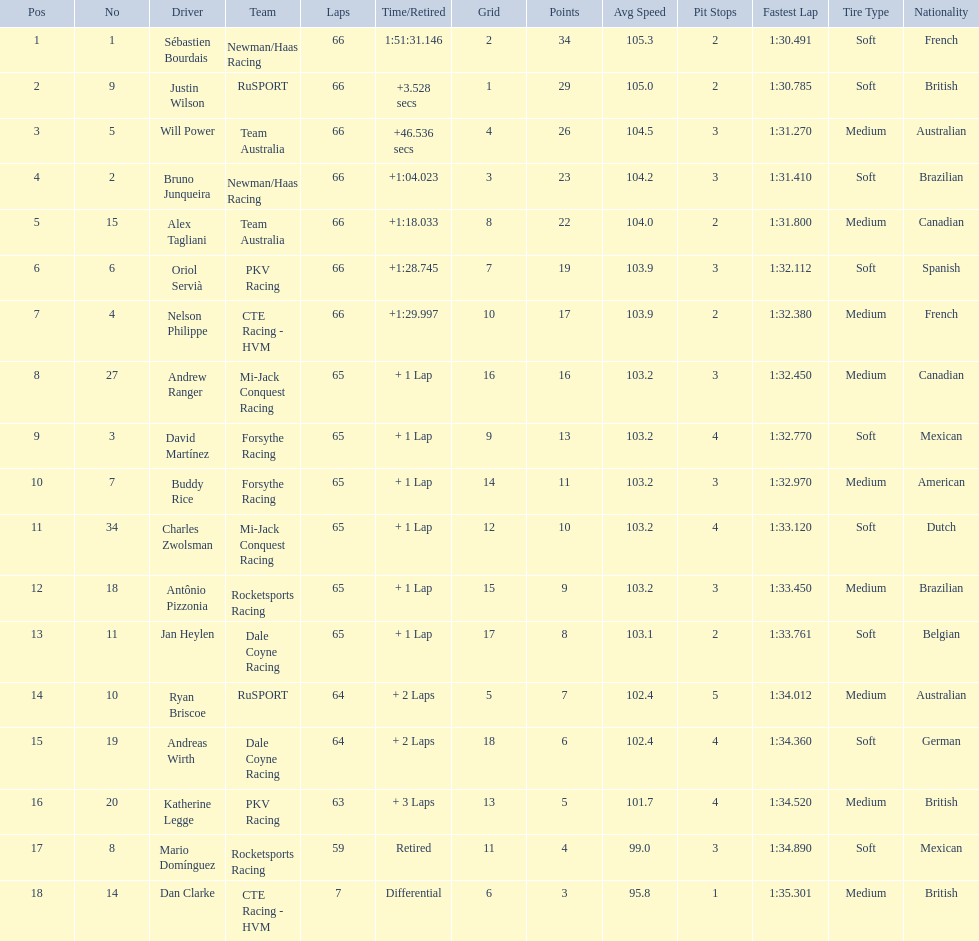At the 2006 gran premio telmex, did oriol servia or katherine legge complete more laps? Oriol Servià. 